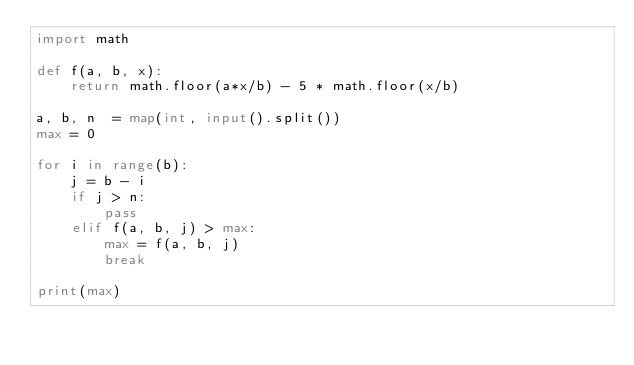Convert code to text. <code><loc_0><loc_0><loc_500><loc_500><_Python_>import math

def f(a, b, x):
    return math.floor(a*x/b) - 5 * math.floor(x/b)

a, b, n  = map(int, input().split())
max = 0

for i in range(b):
    j = b - i
    if j > n:
        pass
    elif f(a, b, j) > max:
        max = f(a, b, j)
        break

print(max)</code> 